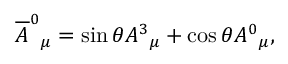Convert formula to latex. <formula><loc_0><loc_0><loc_500><loc_500>\overline { A } ^ { 0 _ { \mu } = \sin { \theta } A ^ { 3 _ { \mu } + \cos { \theta } A ^ { 0 _ { \mu } ,</formula> 